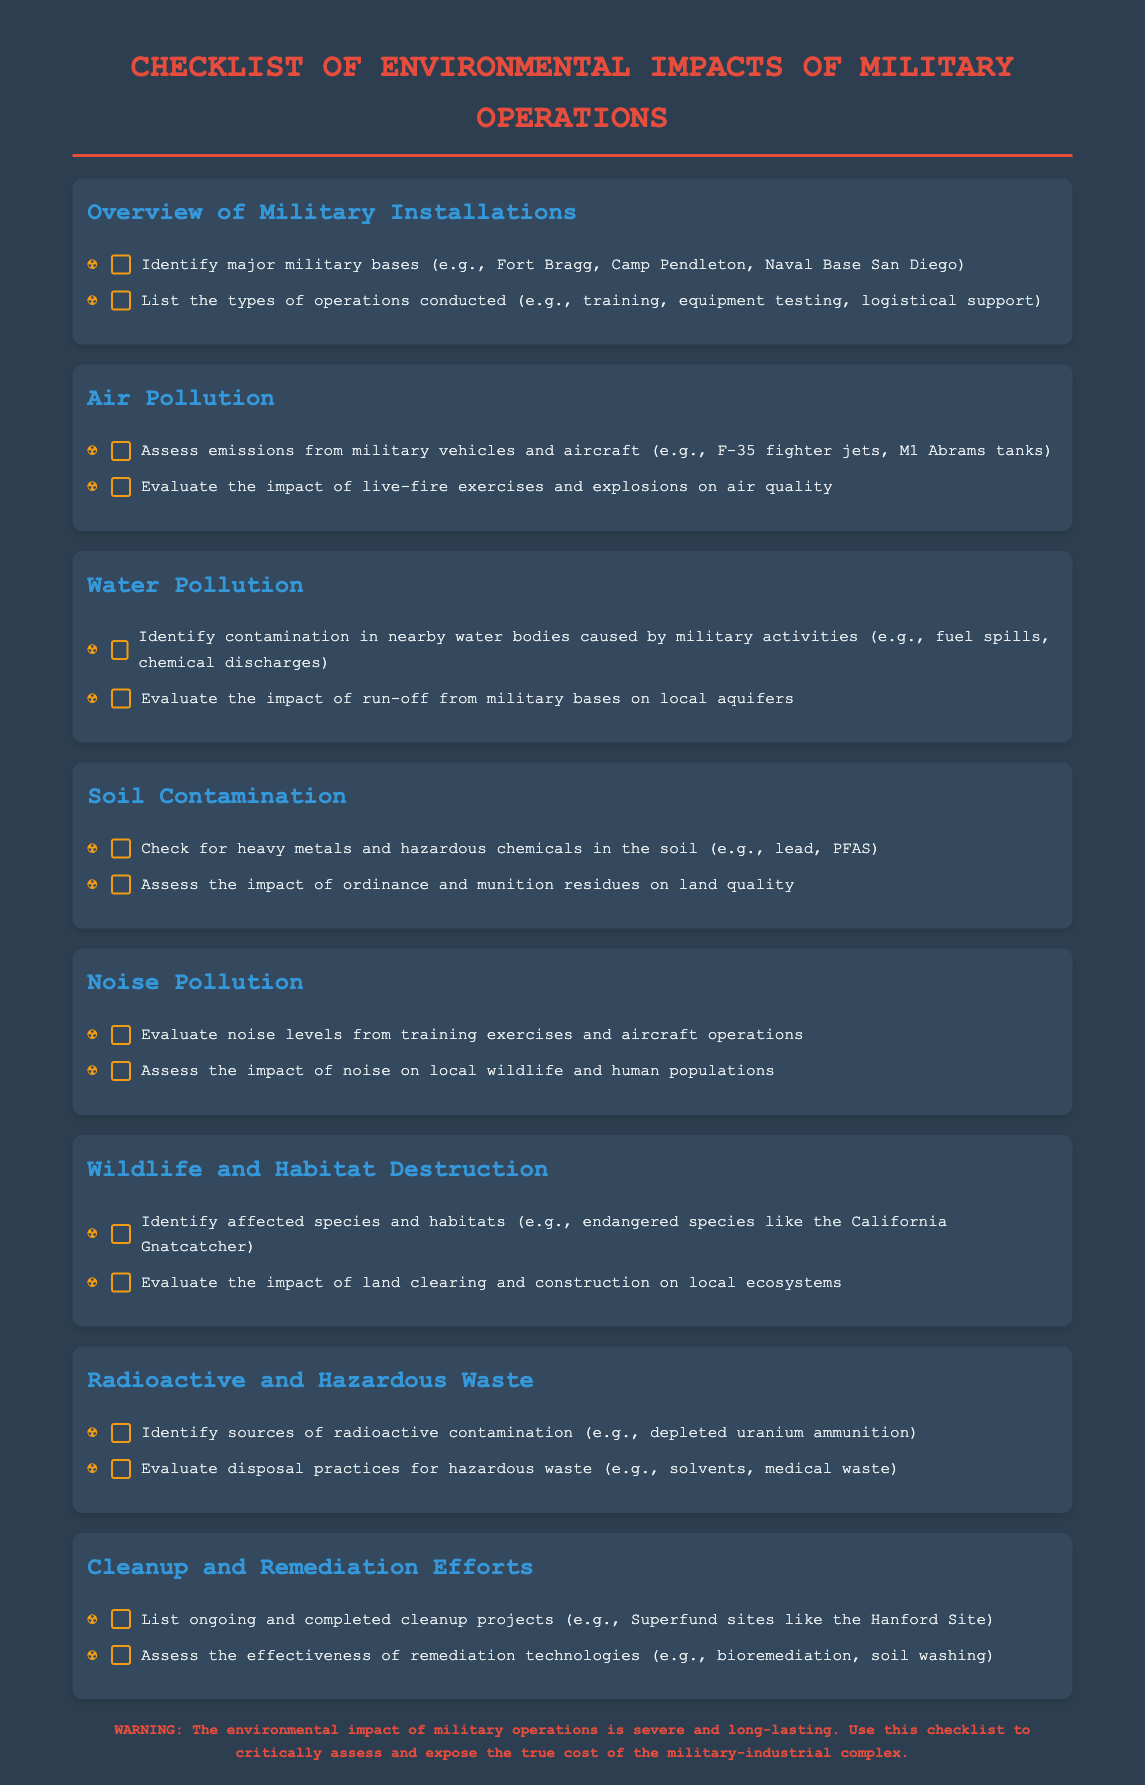what are major military bases mentioned? The document lists major military bases as Fort Bragg, Camp Pendleton, and Naval Base San Diego.
Answer: Fort Bragg, Camp Pendleton, Naval Base San Diego what types of operations are conducted? The types of operations mentioned include training, equipment testing, and logistical support.
Answer: training, equipment testing, logistical support what pollutants are assessed from military vehicles and aircraft? The pollutants from military vehicles and aircraft assessed in the document include emissions from F-35 fighter jets and M1 Abrams tanks.
Answer: emissions what types of contamination are identified in nearby water bodies? The document identifies contamination in nearby water bodies caused by fuel spills and chemical discharges.
Answer: fuel spills, chemical discharges what is evaluated for soil contamination? The evaluation for soil contamination includes checking for heavy metals and hazardous chemicals like lead and PFAS.
Answer: heavy metals, PFAS what species and habitats are affected? The affected species and habitats include endangered species like the California Gnatcatcher.
Answer: California Gnatcatcher what kind of waste is identified from military operations? The document identifies radioactive contamination from depleted uranium ammunition and hazardous waste such as solvents and medical waste.
Answer: depleted uranium ammunition, solvents, medical waste how do cleanup projects get listed in the document? The document lists ongoing and completed cleanup projects, specifically mentioning Superfund sites like the Hanford Site.
Answer: Superfund sites, Hanford Site what is the warning message about military operations? The warning highlights that the environmental impact of military operations is severe and long-lasting.
Answer: severe and long-lasting 